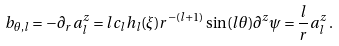<formula> <loc_0><loc_0><loc_500><loc_500>b _ { \theta , l } = - \partial _ { r } a _ { l } ^ { z } = l c _ { l } h _ { l } ( \xi ) r ^ { - ( l + 1 ) } \sin ( l \theta ) \partial ^ { z } \psi = \frac { l } { r } a _ { l } ^ { z } \, .</formula> 